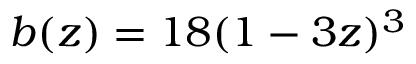<formula> <loc_0><loc_0><loc_500><loc_500>b ( z ) = 1 8 ( 1 - 3 z ) ^ { 3 }</formula> 